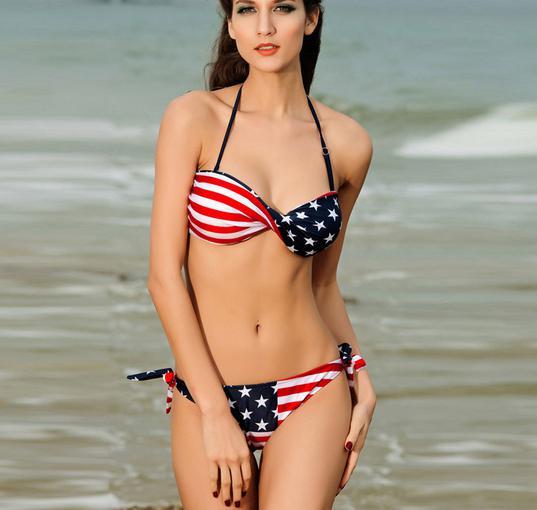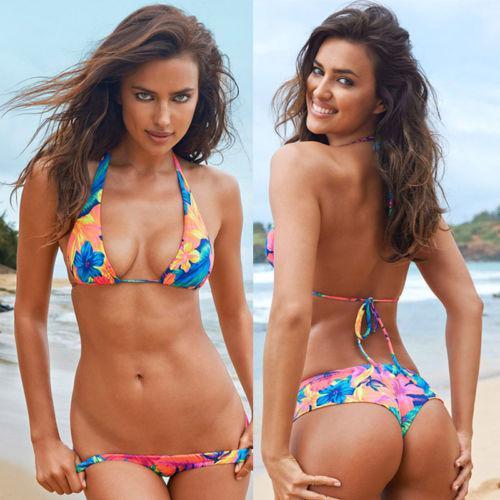The first image is the image on the left, the second image is the image on the right. Considering the images on both sides, is "An image shows a rear view of a bikini and a forward view." valid? Answer yes or no. Yes. The first image is the image on the left, the second image is the image on the right. Examine the images to the left and right. Is the description "There are 4 models in bikinis total" accurate? Answer yes or no. No. 